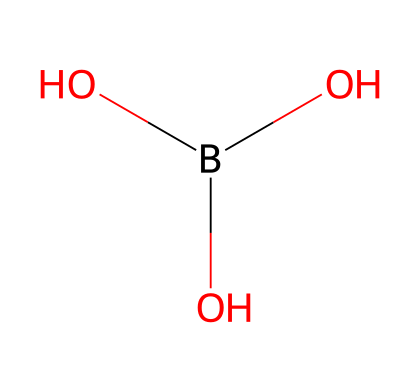What is the name of this chemical? The SMILES representation indicates a structure with one boron atom and three hydroxyl (OH) groups, which is known as boric acid.
Answer: boric acid How many oxygen atoms are present in this structure? The chemical structure shows three hydroxyl groups (each consisting of one oxygen and one hydrogen), indicating that there are three oxygen atoms in total.
Answer: 3 How many total atoms are in this molecule? By counting the individual atoms in the chemical structure: 1 boron atom, 3 oxygen atoms, and 3 hydrogen atoms (from the OH groups), we find a total of 7 atoms.
Answer: 7 What type of chemical bonding is primarily involved in this compound? The presence of OH groups suggests hydrogen bonding capabilities in addition to covalent bonds between boron and oxygen atoms, indicating both are significant in this chemical.
Answer: covalent Does this compound have any antibacterial properties? Boric acid is known for its antibacterial properties, especially in low concentrations, making it suitable for use in preserving materials and preventing microbial growth.
Answer: yes What is the primary use of boric acid in electrical applications? Boric acid is primarily utilized as a flame retardant in electrical insulation materials due to its heat-resistant properties.
Answer: flame retardant Is boric acid an acidic or basic substance? The presence of hydroxyl groups suggests that boric acid can donate protons, indicating it is typically classified as an acidic substance.
Answer: acidic 